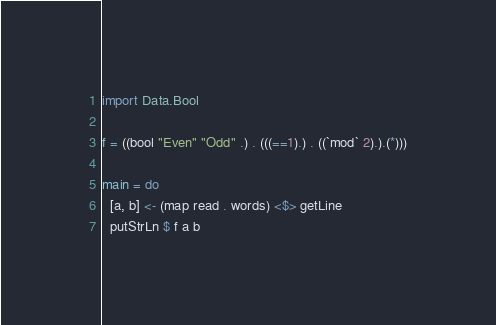Convert code to text. <code><loc_0><loc_0><loc_500><loc_500><_Haskell_>import Data.Bool

f = ((bool "Even" "Odd" .) . (((==1).) . ((`mod` 2).).(*)))

main = do
  [a, b] <- (map read . words) <$> getLine
  putStrLn $ f a b</code> 